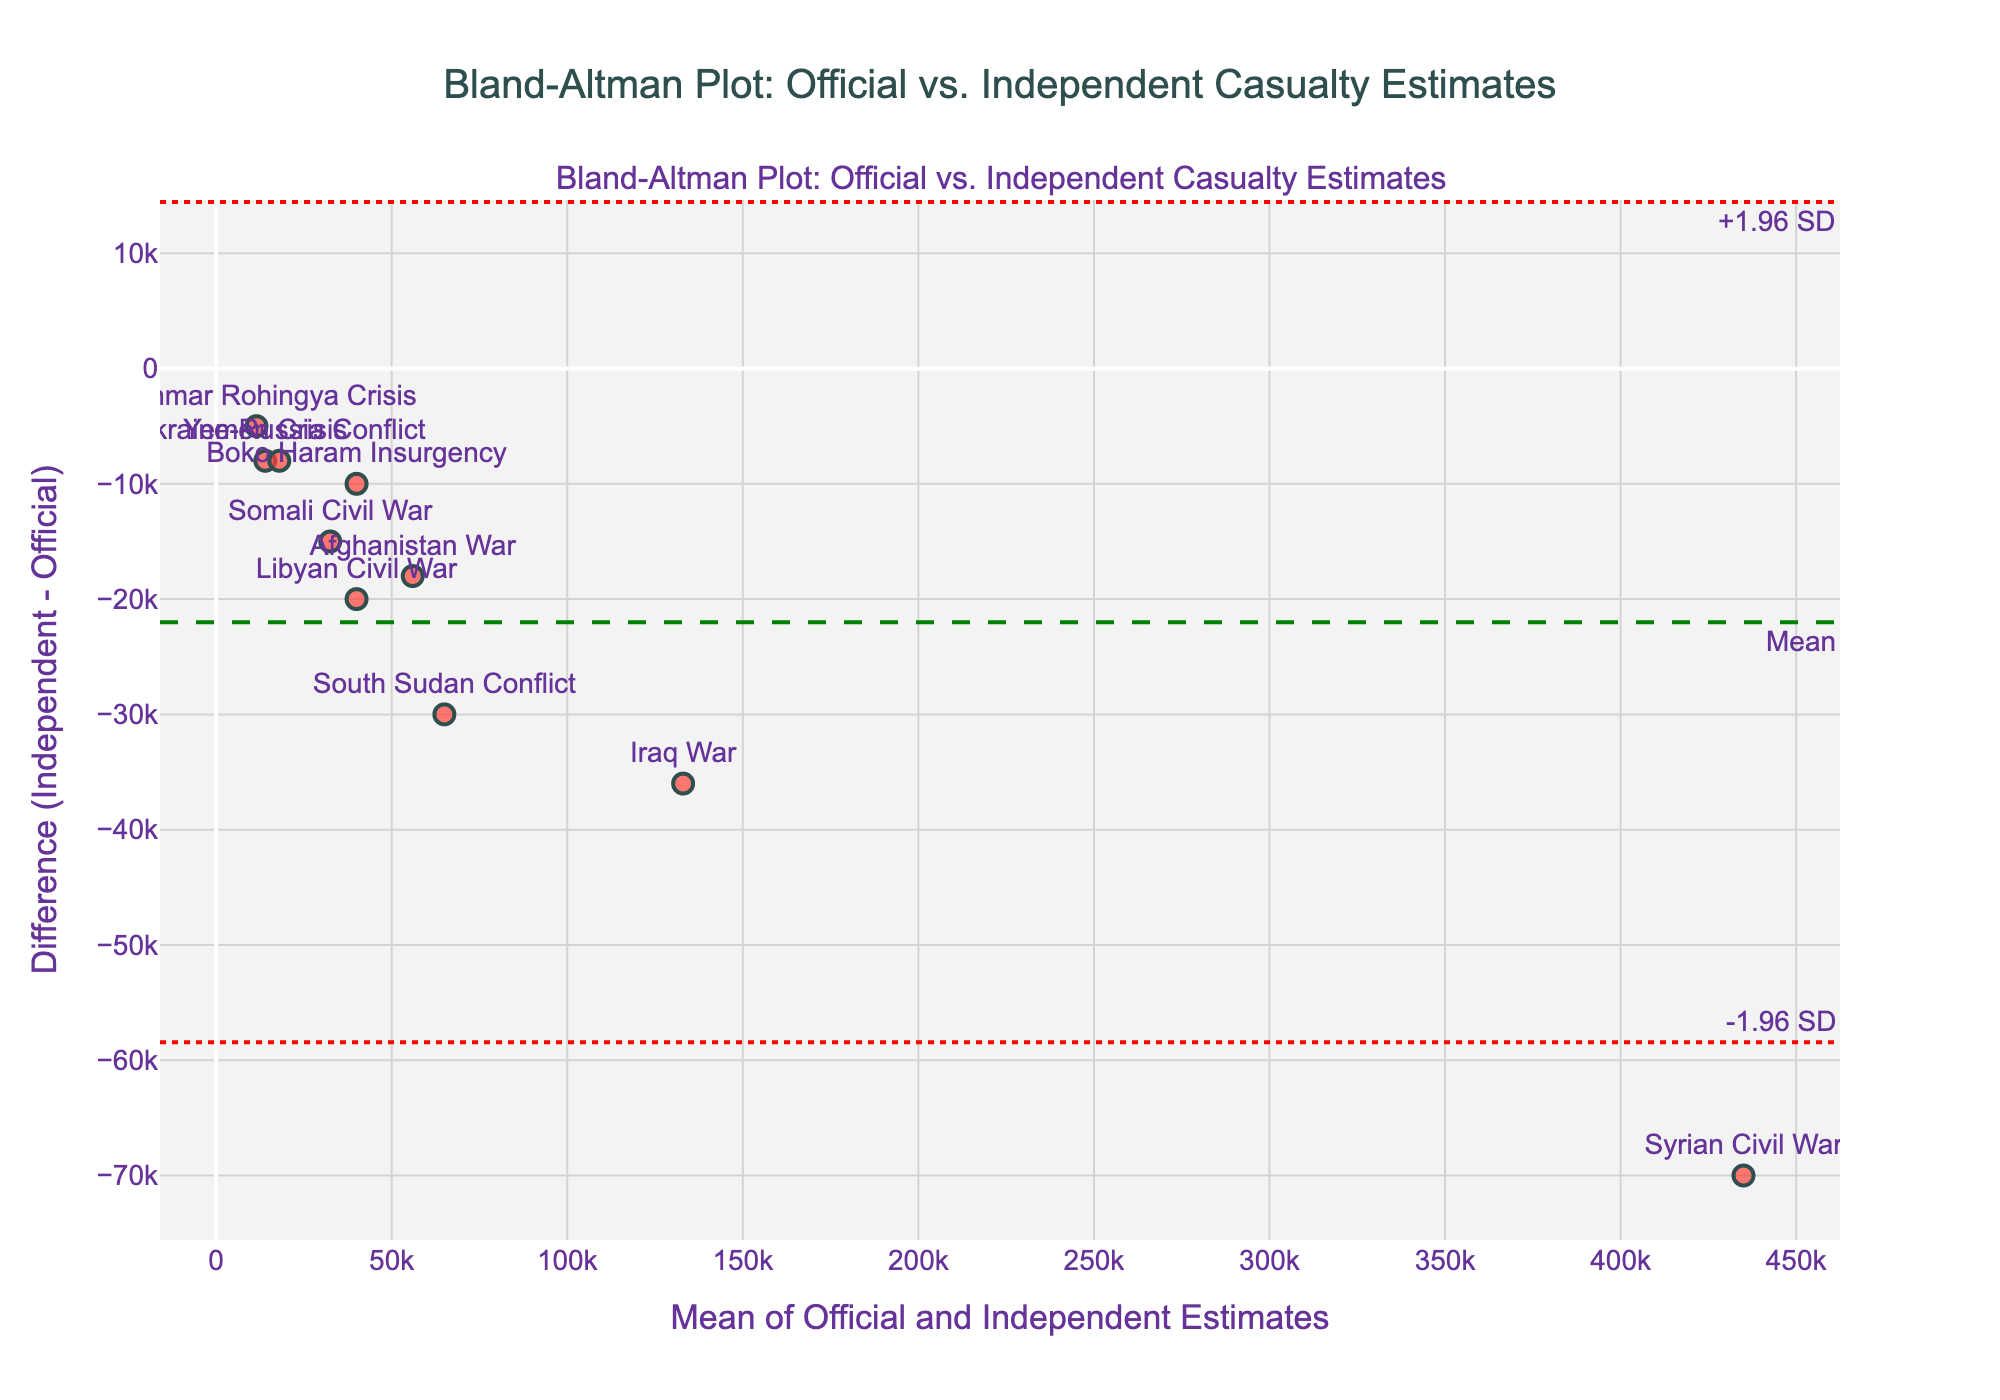How many conflicts are represented in the plot? There are markers on the plot, and each marker corresponds to a different conflict listed in the data. Count the number of unique conflicts visually in the plot.
Answer: 10 What is the mean difference between the independent and official estimates? The green dashed line in the plot represents the mean difference, which is annotated with the text "Mean". Read the value associated with this line.
Answer: -25900 Which conflict has the largest negative difference between the independent and official estimates? Look for the marker that is furthest below the zero line on the y-axis. The conflict associated with this marker has the largest negative difference.
Answer: Syrian Civil War What is the mean estimate for the Ukraine-Russia Conflict? Locate the marker labeled "Ukraine-Russia Conflict" and read the x-axis value, which represents the mean of the official and independent estimates.
Answer: 18000 Is the mean difference line above or below zero? Observe the position of the green dashed "Mean" line relative to the zero line on the y-axis.
Answer: Below Which conflicts have differences that fall outside the ±1.96 SD range? Look for the markers that are outside the red dotted lines labeled "+1.96 SD" and "-1.96 SD". Identify the conflicts associated with these markers.
Answer: Syrian Civil War, Iraq War, South Sudan Conflict, Somali Civil War How many conflicts have a mean estimate greater than 50,000? Count the markers on the plot that are positioned to the right of the 50,000 mark on the x-axis.
Answer: 4 What does the x-axis represent in this plot? The x-axis in a Bland-Altman plot represents the mean of the official and independent estimates for each conflict.
Answer: Mean of official and independent estimates Which conflict has the smallest mean estimate? Look for the marker closest to the left end of the x-axis and identify the conflict associated with it.
Answer: Myanmar Rohingya Crisis What is the standard deviation of the differences? The +/- 1.96 SD lines are used in the plot, and their positions relative to the mean difference line can be used to deduce the standard deviation. Calculate the difference between one of these lines and the mean difference line, then divide by 1.96.
Answer: 23646 